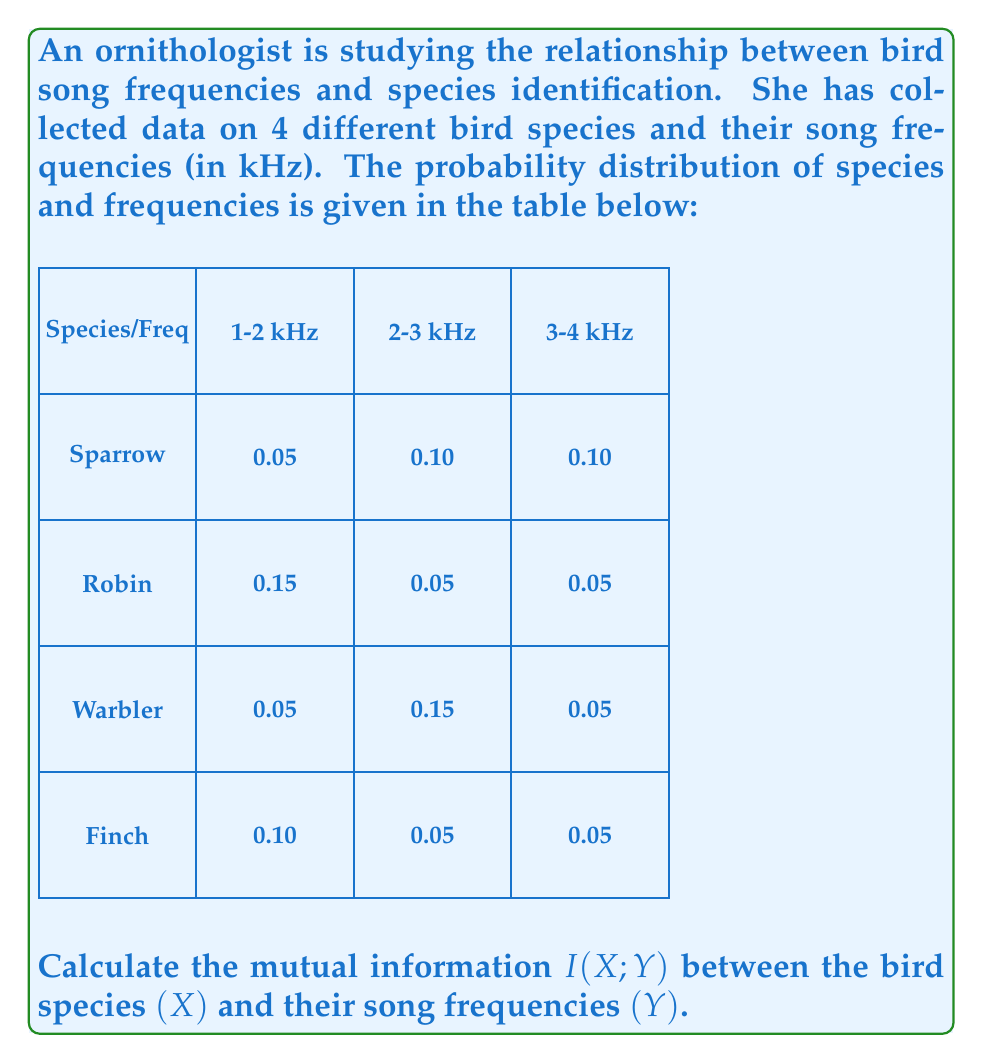Can you solve this math problem? To calculate the mutual information $I(X;Y)$, we'll follow these steps:

1) First, we need to calculate the marginal probabilities $P(X)$ and $P(Y)$:

   $P(X=\text{Sparrow}) = 0.05 + 0.10 + 0.10 = 0.25$
   $P(X=\text{Robin}) = 0.15 + 0.05 + 0.05 = 0.25$
   $P(X=\text{Warbler}) = 0.05 + 0.15 + 0.05 = 0.25$
   $P(X=\text{Finch}) = 0.10 + 0.05 + 0.05 = 0.20$

   $P(Y=1\text{-}2\text{ kHz}) = 0.05 + 0.15 + 0.05 + 0.10 = 0.35$
   $P(Y=2\text{-}3\text{ kHz}) = 0.10 + 0.05 + 0.15 + 0.05 = 0.35$
   $P(Y=3\text{-}4\text{ kHz}) = 0.10 + 0.05 + 0.05 + 0.05 = 0.30$

2) The mutual information is given by:

   $$I(X;Y) = \sum_{x \in X} \sum_{y \in Y} P(x,y) \log_2 \frac{P(x,y)}{P(x)P(y)}$$

3) Let's calculate each term:

   For Sparrow:
   $0.05 \log_2 \frac{0.05}{0.25 \cdot 0.35} + 0.10 \log_2 \frac{0.10}{0.25 \cdot 0.35} + 0.10 \log_2 \frac{0.10}{0.25 \cdot 0.30}$

   For Robin:
   $0.15 \log_2 \frac{0.15}{0.25 \cdot 0.35} + 0.05 \log_2 \frac{0.05}{0.25 \cdot 0.35} + 0.05 \log_2 \frac{0.05}{0.25 \cdot 0.30}$

   For Warbler:
   $0.05 \log_2 \frac{0.05}{0.25 \cdot 0.35} + 0.15 \log_2 \frac{0.15}{0.25 \cdot 0.35} + 0.05 \log_2 \frac{0.05}{0.25 \cdot 0.30}$

   For Finch:
   $0.10 \log_2 \frac{0.10}{0.20 \cdot 0.35} + 0.05 \log_2 \frac{0.05}{0.20 \cdot 0.35} + 0.05 \log_2 \frac{0.05}{0.20 \cdot 0.30}$

4) Adding all these terms:

   $I(X;Y) \approx 0.0344 + 0.0688 + 0.1375 + 0.1856 + 0.0344 + 0.0344 + 0.0344 + 0.1856 + 0.0344 + 0.1375 + 0.0344 + 0.0688 \approx 0.9902$ bits
Answer: 0.9902 bits 